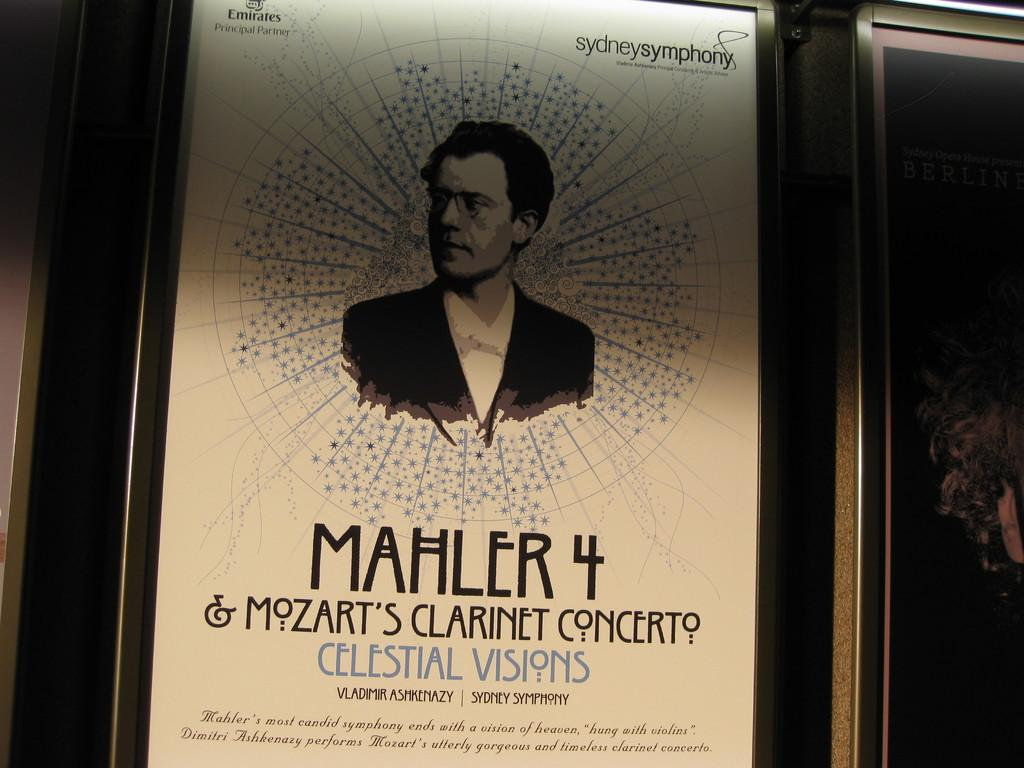<image>
Summarize the visual content of the image. AN ADVERTISEMENT HANGING ON A WALL AND IT READS SYDNEY SYMPHONY 